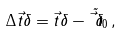Convert formula to latex. <formula><loc_0><loc_0><loc_500><loc_500>\Delta \vec { t } { \delta } = \vec { t } { \delta } - \tilde { \vec { t } { \delta } } _ { 0 } \, ,</formula> 